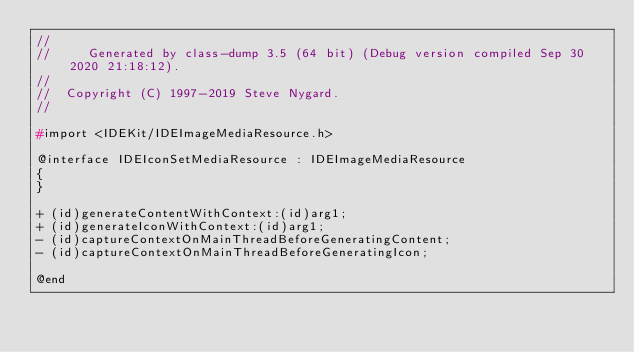<code> <loc_0><loc_0><loc_500><loc_500><_C_>//
//     Generated by class-dump 3.5 (64 bit) (Debug version compiled Sep 30 2020 21:18:12).
//
//  Copyright (C) 1997-2019 Steve Nygard.
//

#import <IDEKit/IDEImageMediaResource.h>

@interface IDEIconSetMediaResource : IDEImageMediaResource
{
}

+ (id)generateContentWithContext:(id)arg1;
+ (id)generateIconWithContext:(id)arg1;
- (id)captureContextOnMainThreadBeforeGeneratingContent;
- (id)captureContextOnMainThreadBeforeGeneratingIcon;

@end

</code> 